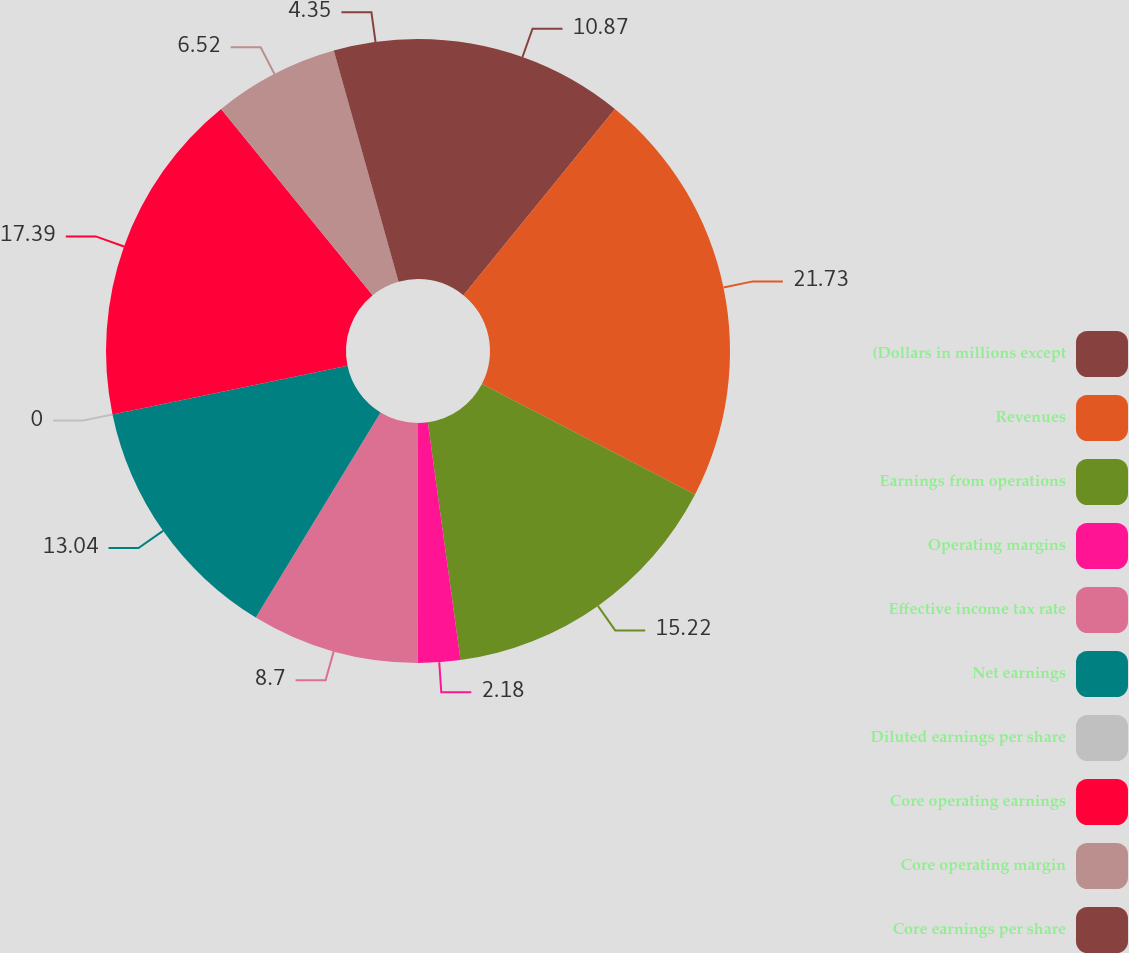<chart> <loc_0><loc_0><loc_500><loc_500><pie_chart><fcel>(Dollars in millions except<fcel>Revenues<fcel>Earnings from operations<fcel>Operating margins<fcel>Effective income tax rate<fcel>Net earnings<fcel>Diluted earnings per share<fcel>Core operating earnings<fcel>Core operating margin<fcel>Core earnings per share<nl><fcel>10.87%<fcel>21.74%<fcel>15.22%<fcel>2.18%<fcel>8.7%<fcel>13.04%<fcel>0.0%<fcel>17.39%<fcel>6.52%<fcel>4.35%<nl></chart> 